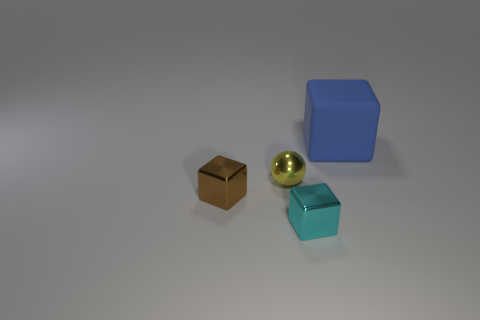Subtract all blue matte cubes. How many cubes are left? 2 Add 1 small cyan metallic things. How many objects exist? 5 Subtract all balls. How many objects are left? 3 Add 4 big red shiny balls. How many big red shiny balls exist? 4 Subtract 0 blue balls. How many objects are left? 4 Subtract all large blue objects. Subtract all cyan objects. How many objects are left? 2 Add 1 big cubes. How many big cubes are left? 2 